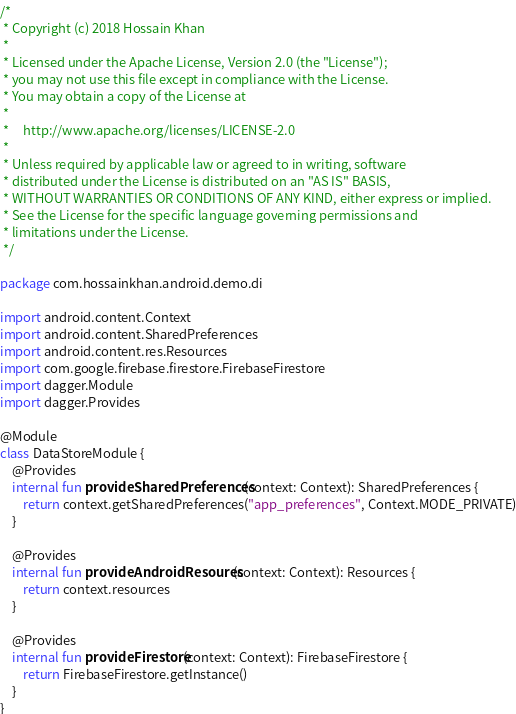Convert code to text. <code><loc_0><loc_0><loc_500><loc_500><_Kotlin_>/*
 * Copyright (c) 2018 Hossain Khan
 *
 * Licensed under the Apache License, Version 2.0 (the "License");
 * you may not use this file except in compliance with the License.
 * You may obtain a copy of the License at
 *
 *     http://www.apache.org/licenses/LICENSE-2.0
 *
 * Unless required by applicable law or agreed to in writing, software
 * distributed under the License is distributed on an "AS IS" BASIS,
 * WITHOUT WARRANTIES OR CONDITIONS OF ANY KIND, either express or implied.
 * See the License for the specific language governing permissions and
 * limitations under the License.
 */

package com.hossainkhan.android.demo.di

import android.content.Context
import android.content.SharedPreferences
import android.content.res.Resources
import com.google.firebase.firestore.FirebaseFirestore
import dagger.Module
import dagger.Provides

@Module
class DataStoreModule {
    @Provides
    internal fun provideSharedPreferences(context: Context): SharedPreferences {
        return context.getSharedPreferences("app_preferences", Context.MODE_PRIVATE)
    }

    @Provides
    internal fun provideAndroidResoures(context: Context): Resources {
        return context.resources
    }

    @Provides
    internal fun provideFirestore(context: Context): FirebaseFirestore {
        return FirebaseFirestore.getInstance()
    }
}
</code> 